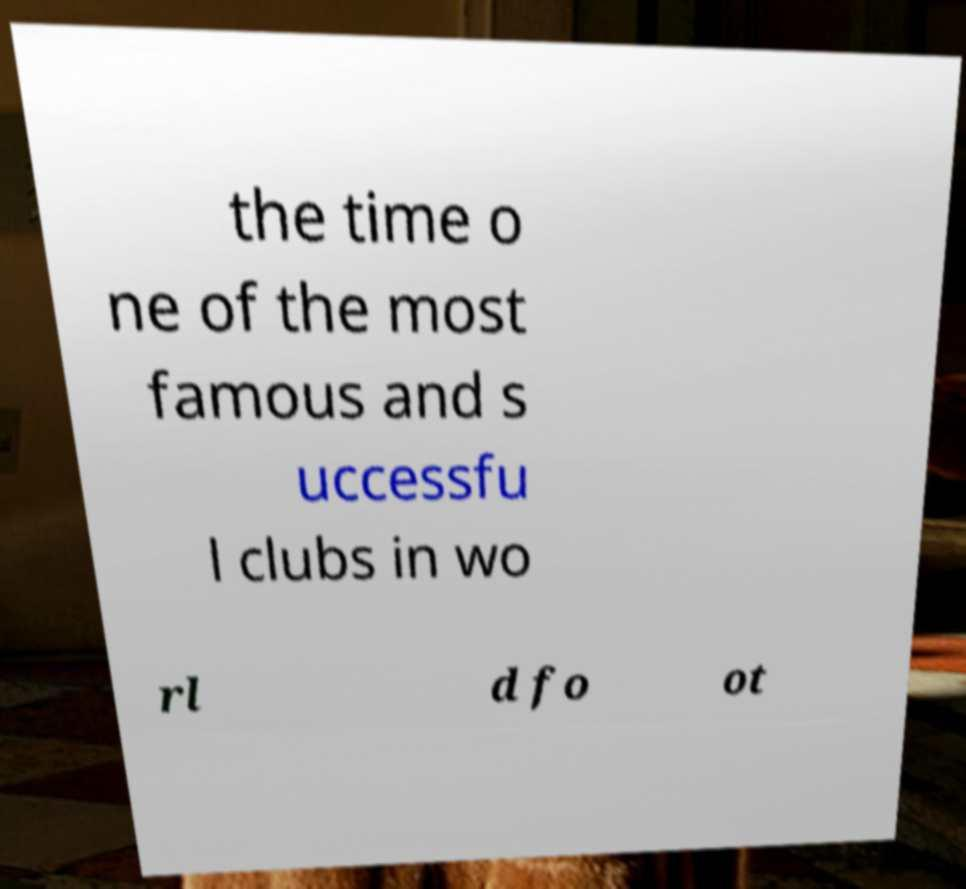There's text embedded in this image that I need extracted. Can you transcribe it verbatim? the time o ne of the most famous and s uccessfu l clubs in wo rl d fo ot 